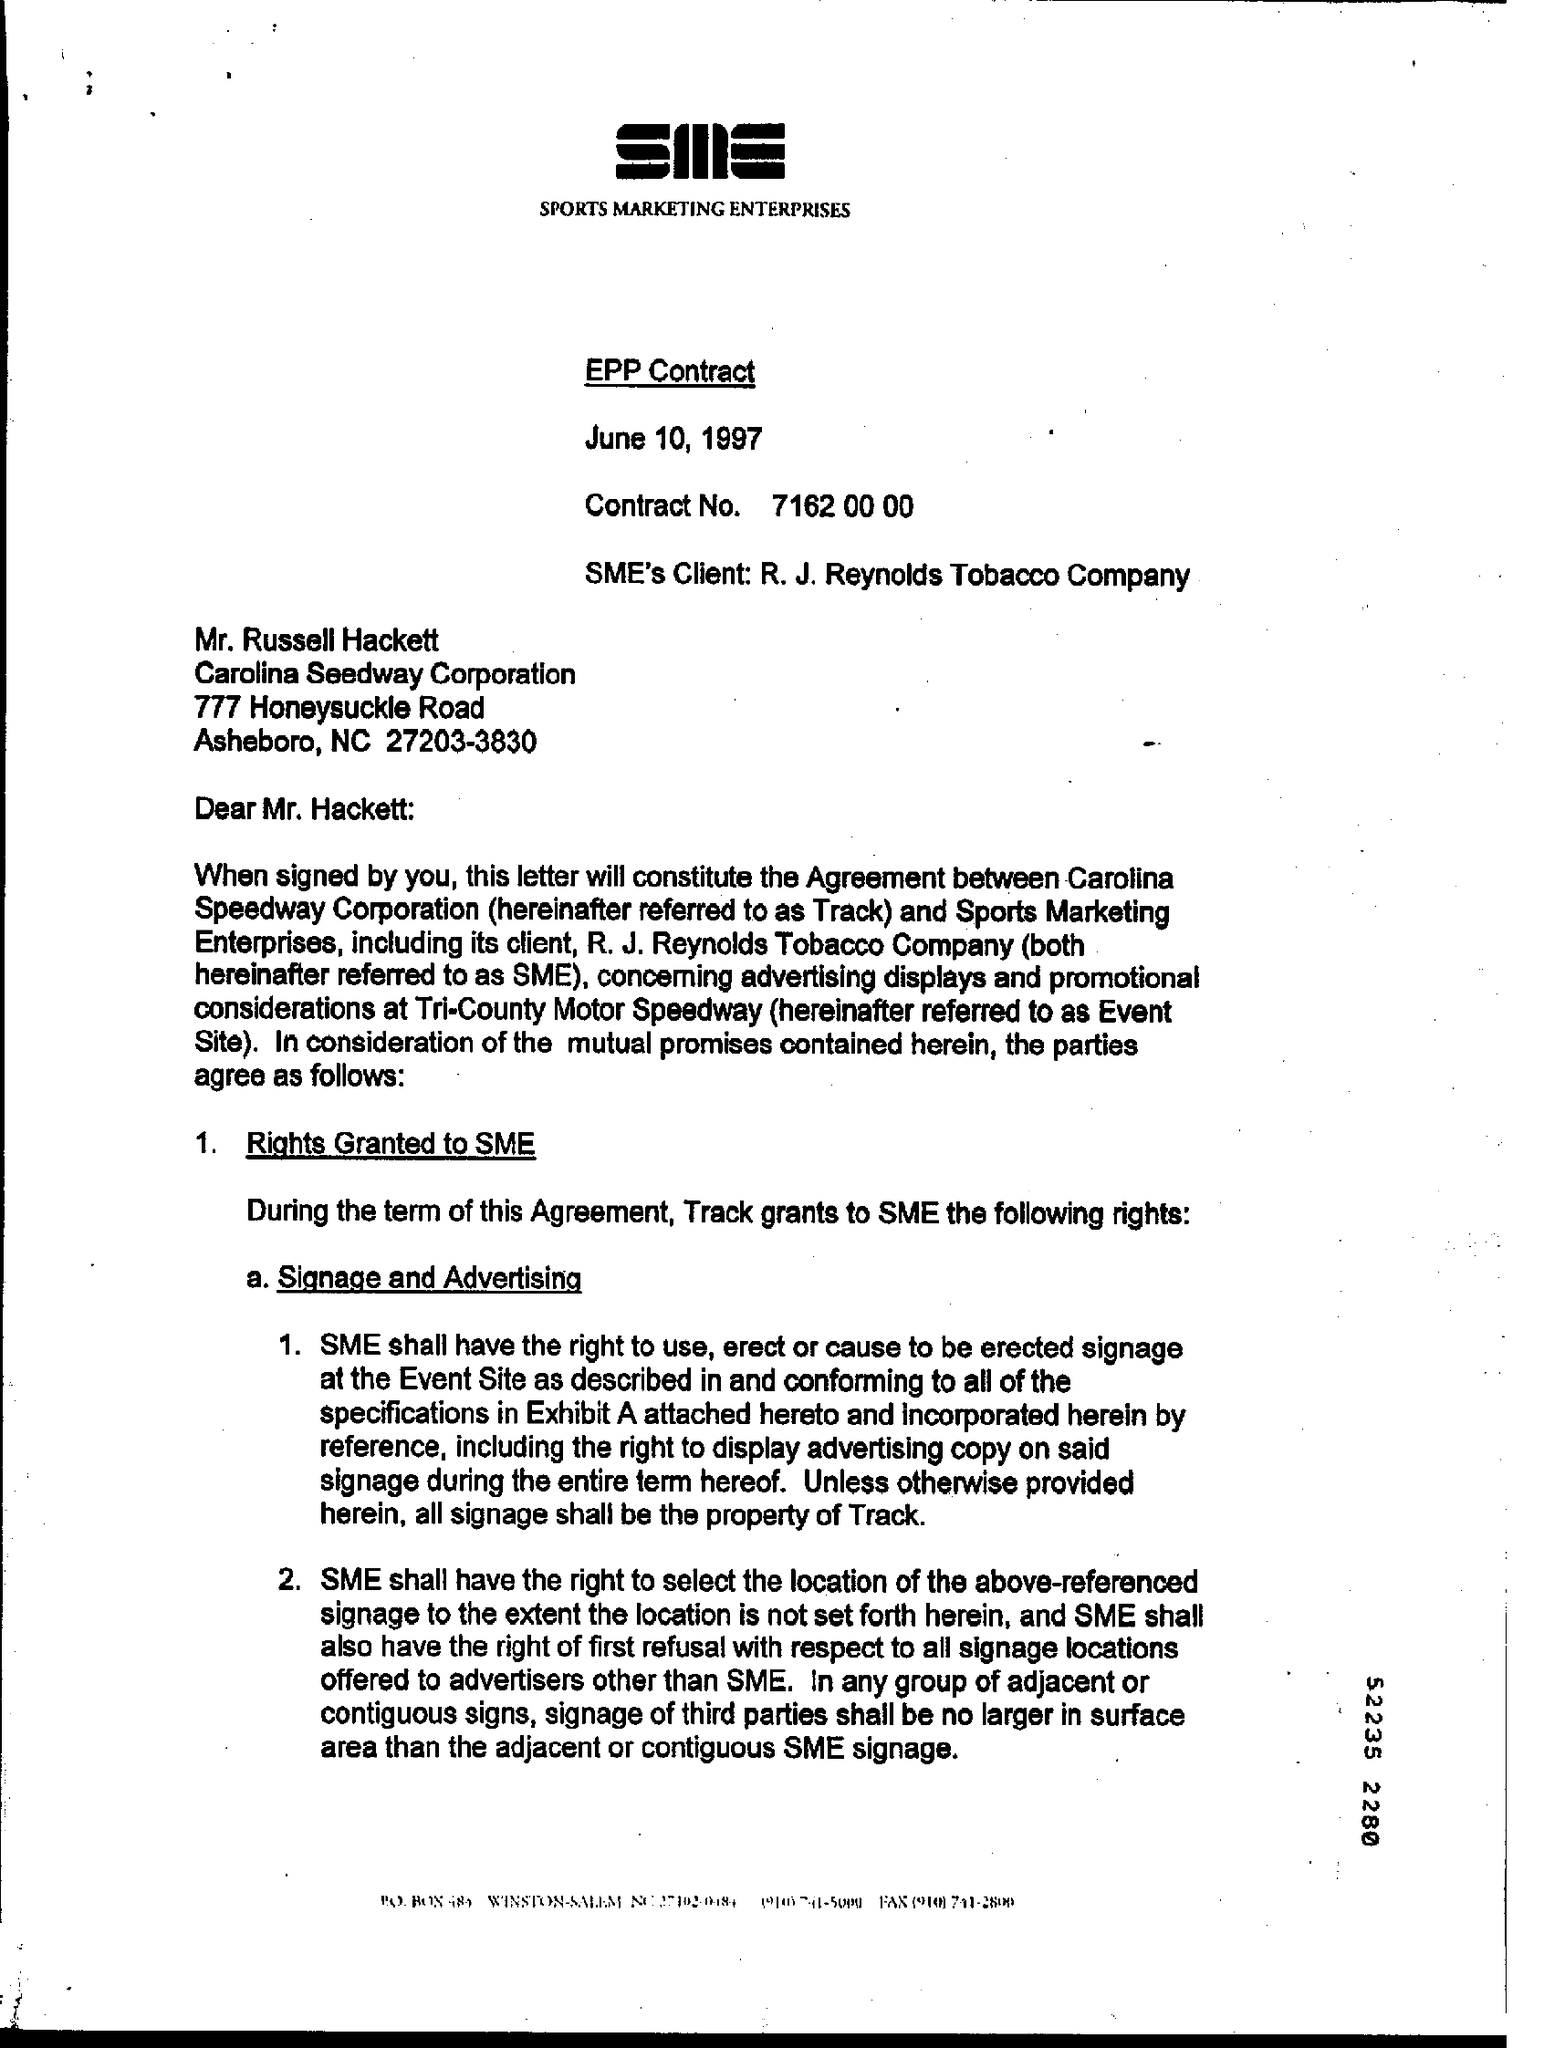Indicate a few pertinent items in this graphic. The SME's client is R. J. Reynolds Tobacco Company. The Contract No. is 7162 00 00. Mr. Russell Hackett is associated with the Carolina Seedway Corporation. 